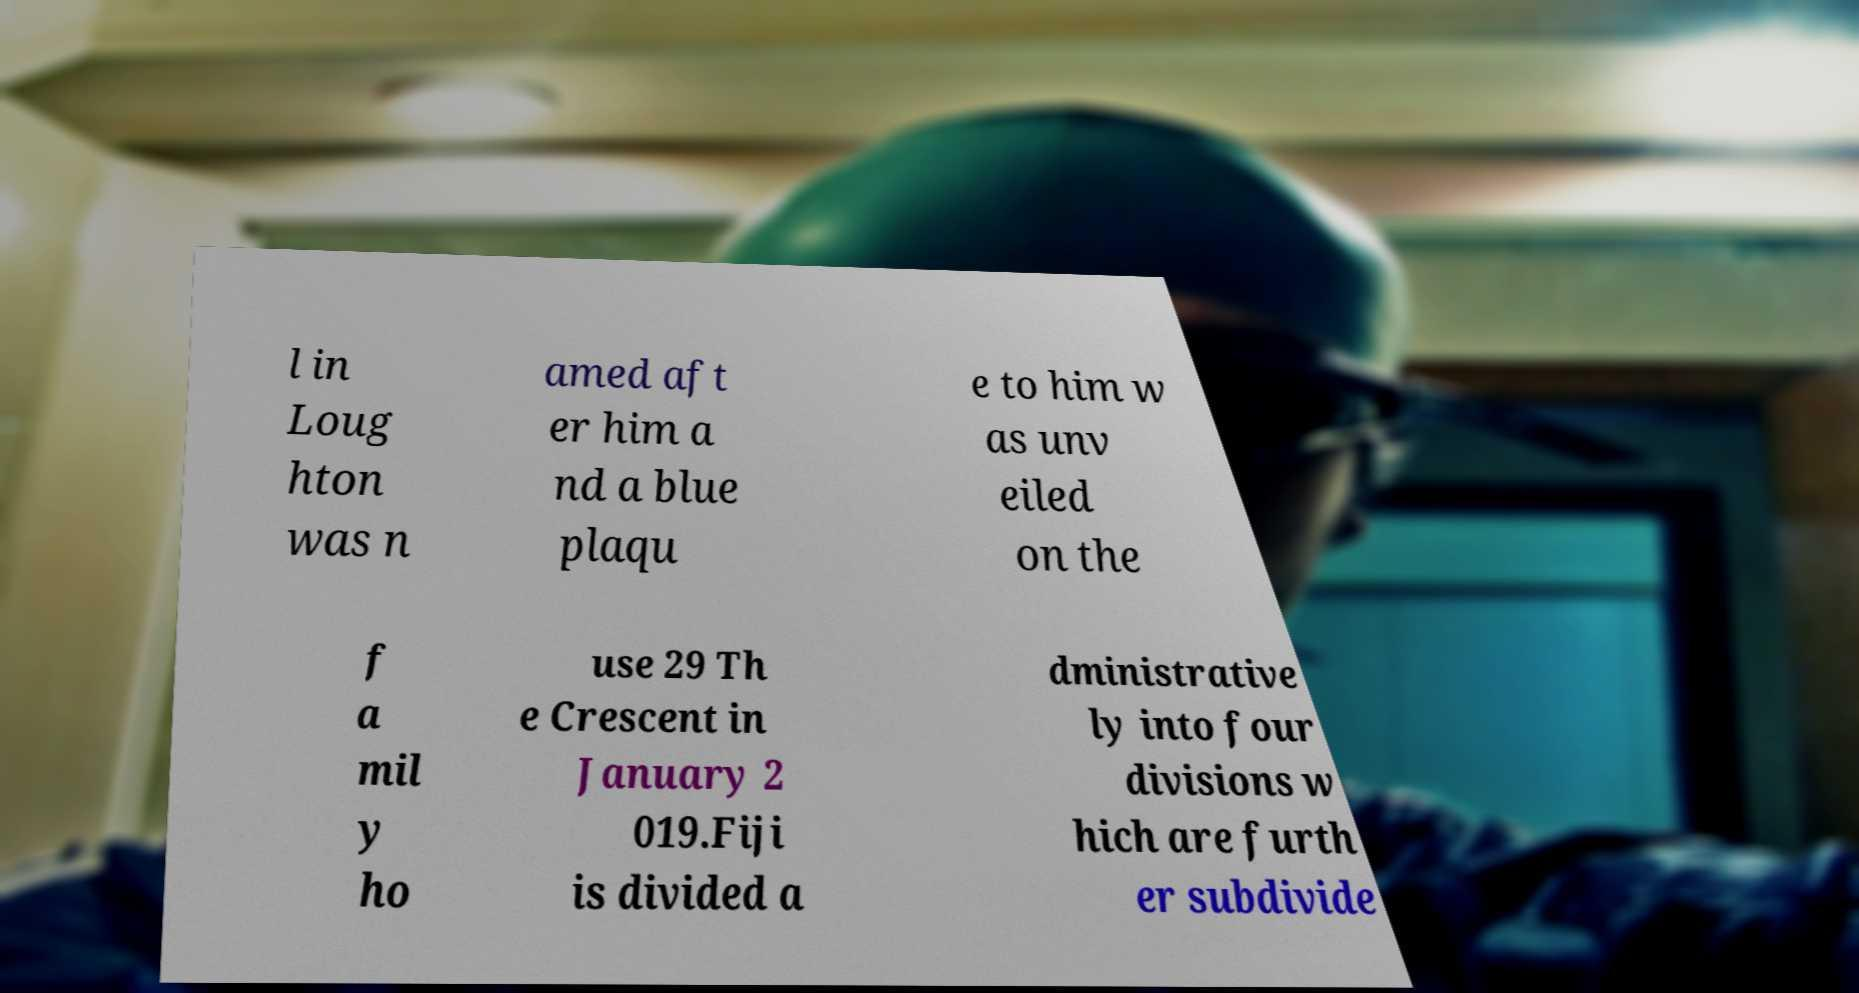Please identify and transcribe the text found in this image. l in Loug hton was n amed aft er him a nd a blue plaqu e to him w as unv eiled on the f a mil y ho use 29 Th e Crescent in January 2 019.Fiji is divided a dministrative ly into four divisions w hich are furth er subdivide 